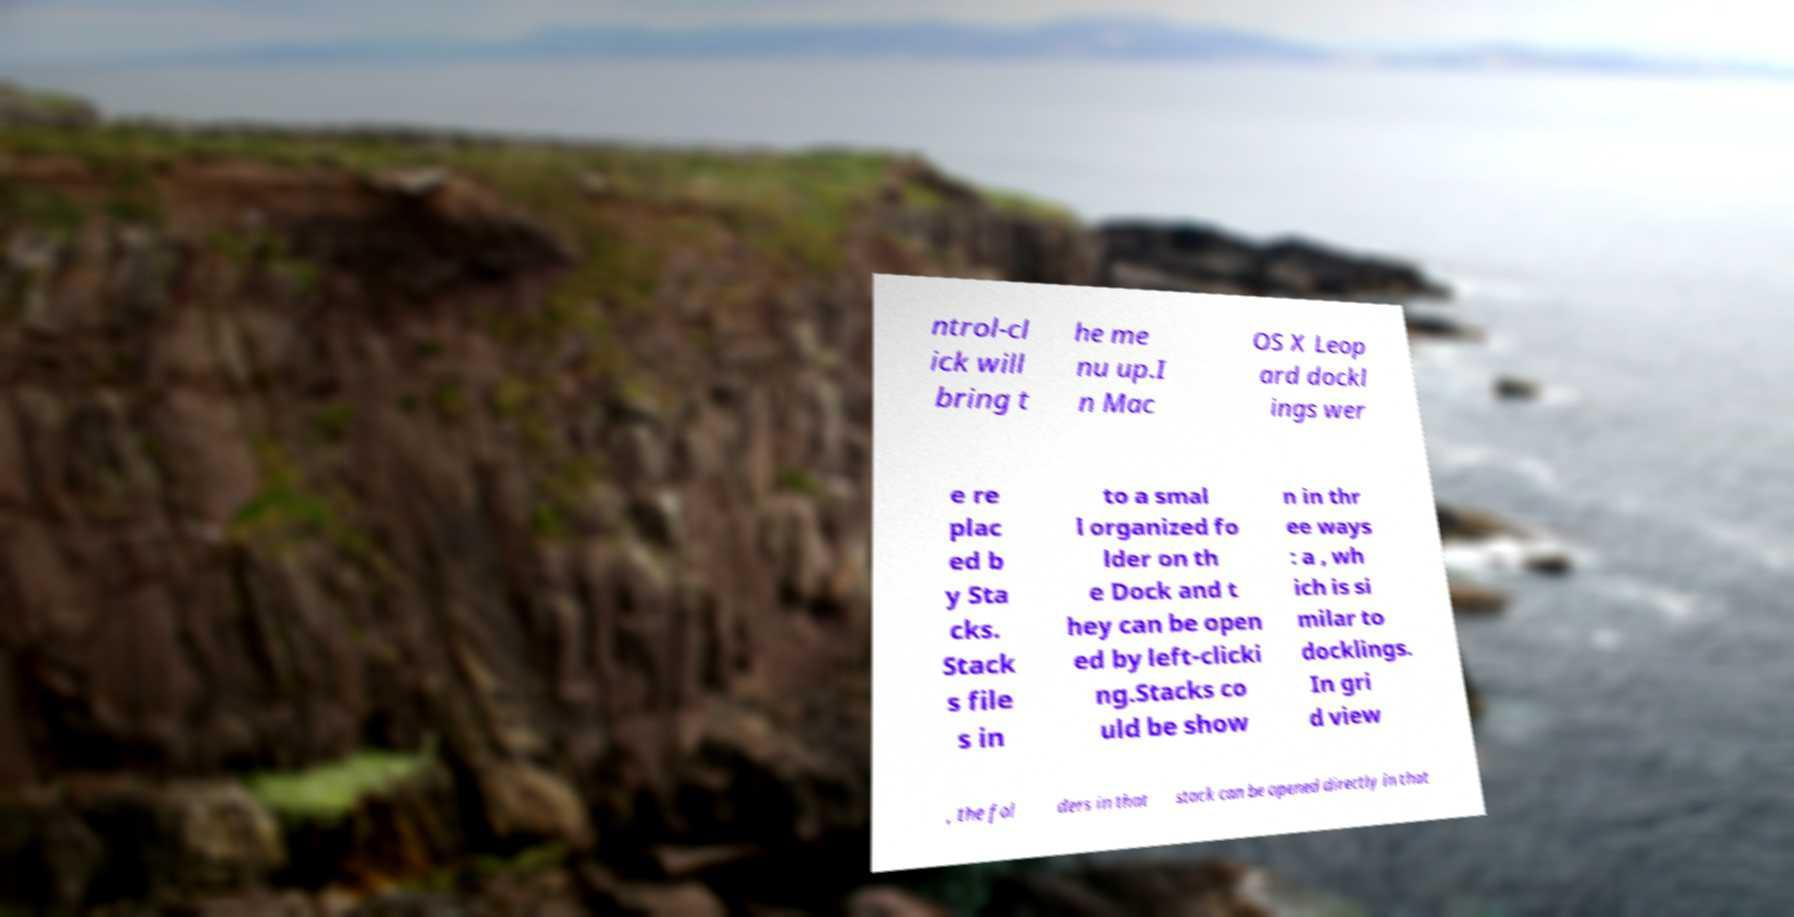Please read and relay the text visible in this image. What does it say? ntrol-cl ick will bring t he me nu up.I n Mac OS X Leop ard dockl ings wer e re plac ed b y Sta cks. Stack s file s in to a smal l organized fo lder on th e Dock and t hey can be open ed by left-clicki ng.Stacks co uld be show n in thr ee ways : a , wh ich is si milar to docklings. In gri d view , the fol ders in that stack can be opened directly in that 